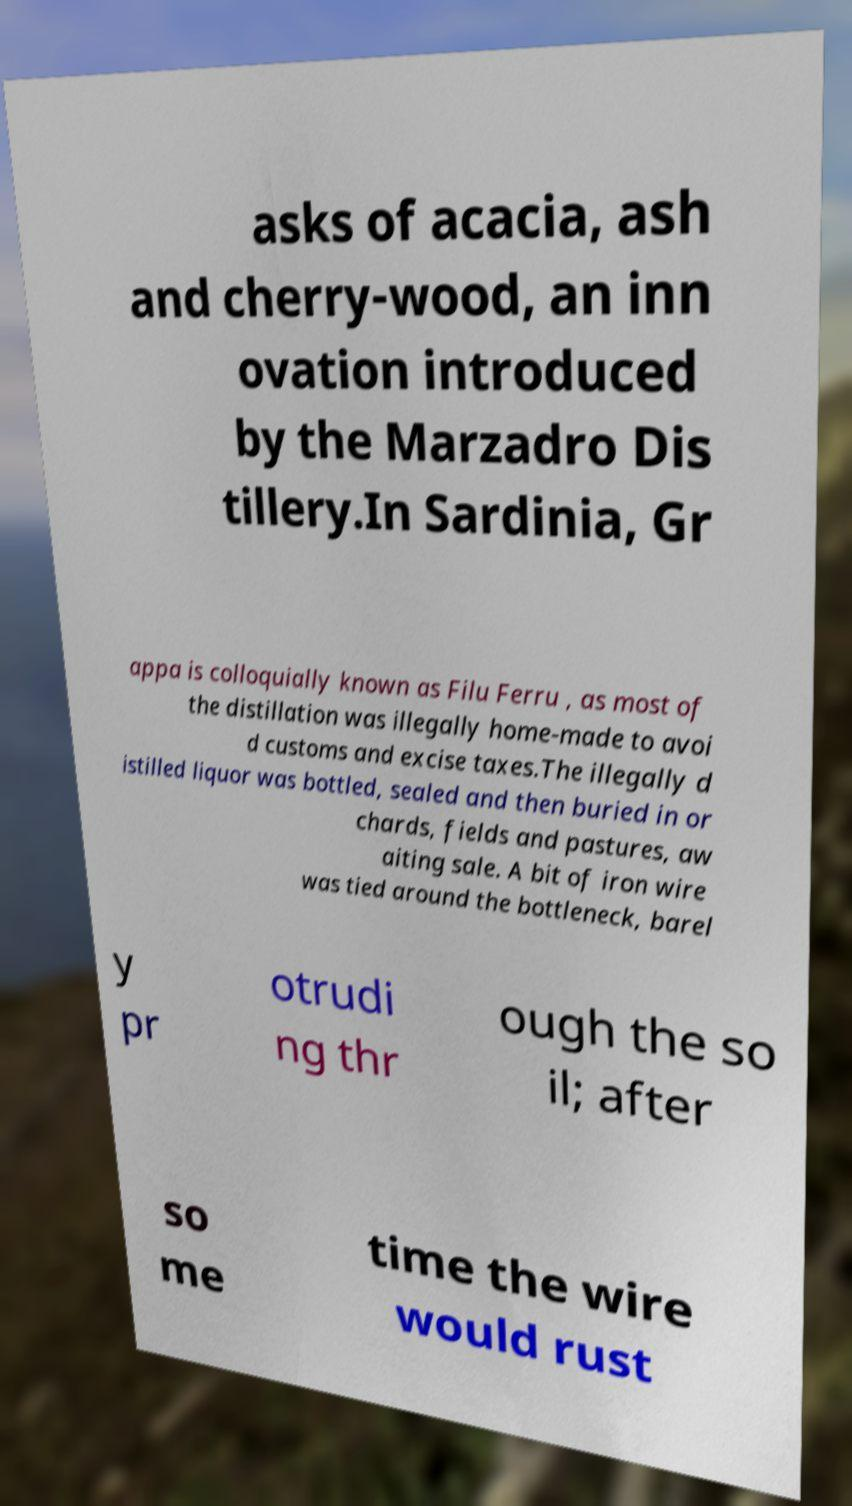Could you assist in decoding the text presented in this image and type it out clearly? asks of acacia, ash and cherry-wood, an inn ovation introduced by the Marzadro Dis tillery.In Sardinia, Gr appa is colloquially known as Filu Ferru , as most of the distillation was illegally home-made to avoi d customs and excise taxes.The illegally d istilled liquor was bottled, sealed and then buried in or chards, fields and pastures, aw aiting sale. A bit of iron wire was tied around the bottleneck, barel y pr otrudi ng thr ough the so il; after so me time the wire would rust 